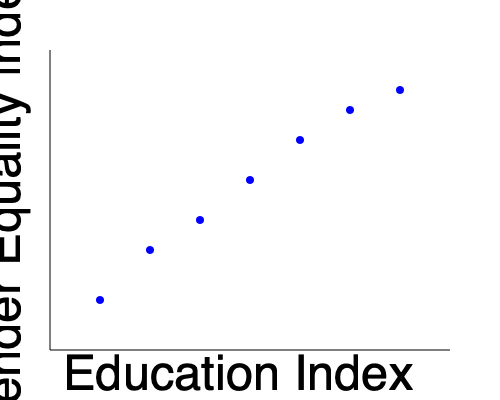Based on the scatter plot showing the relationship between the Education Index and Gender Equality Index for various countries, what can be inferred about the correlation between education level and gender equality? How would you quantify this relationship, and what implications does this have for policy-making in developing countries? 1. Observe the scatter plot: The points show a clear downward trend from left to right, indicating a negative correlation between the Education Index (x-axis) and the Gender Equality Index (y-axis).

2. Interpret the axes:
   - Higher values on the x-axis represent higher levels of education.
   - Lower values on the y-axis represent better gender equality (as 0 typically represents perfect equality in such indices).

3. Analyze the correlation:
   - The negative correlation actually indicates a positive relationship between education and gender equality.
   - As education levels increase (moving right on the x-axis), gender equality improves (moving down on the y-axis).

4. Quantify the relationship:
   - We could calculate the Pearson correlation coefficient (r) to measure the strength of the linear relationship.
   - Visually, the relationship appears strong, so we might expect |r| > 0.7.

5. Consider implications:
   - The strong correlation suggests that improving education levels could be an effective strategy for enhancing gender equality.
   - Policy-makers in developing countries might prioritize education initiatives as a means to address gender inequality.
   - However, correlation does not imply causation, so other factors should also be considered.

6. Limitations:
   - The plot doesn't show causation, only correlation.
   - Other variables not shown might influence both education and gender equality.
   - The relationship might not be perfectly linear, and there could be outliers or clusters not visible in this simplified plot.

7. Future research:
   - Investigate potential causal mechanisms linking education to gender equality.
   - Examine how this relationship varies across different regions or cultural contexts.
   - Consider longitudinal studies to track changes in both variables over time.
Answer: Strong positive correlation between education level and gender equality, suggesting education may be a key factor in promoting gender equality in developing countries. 